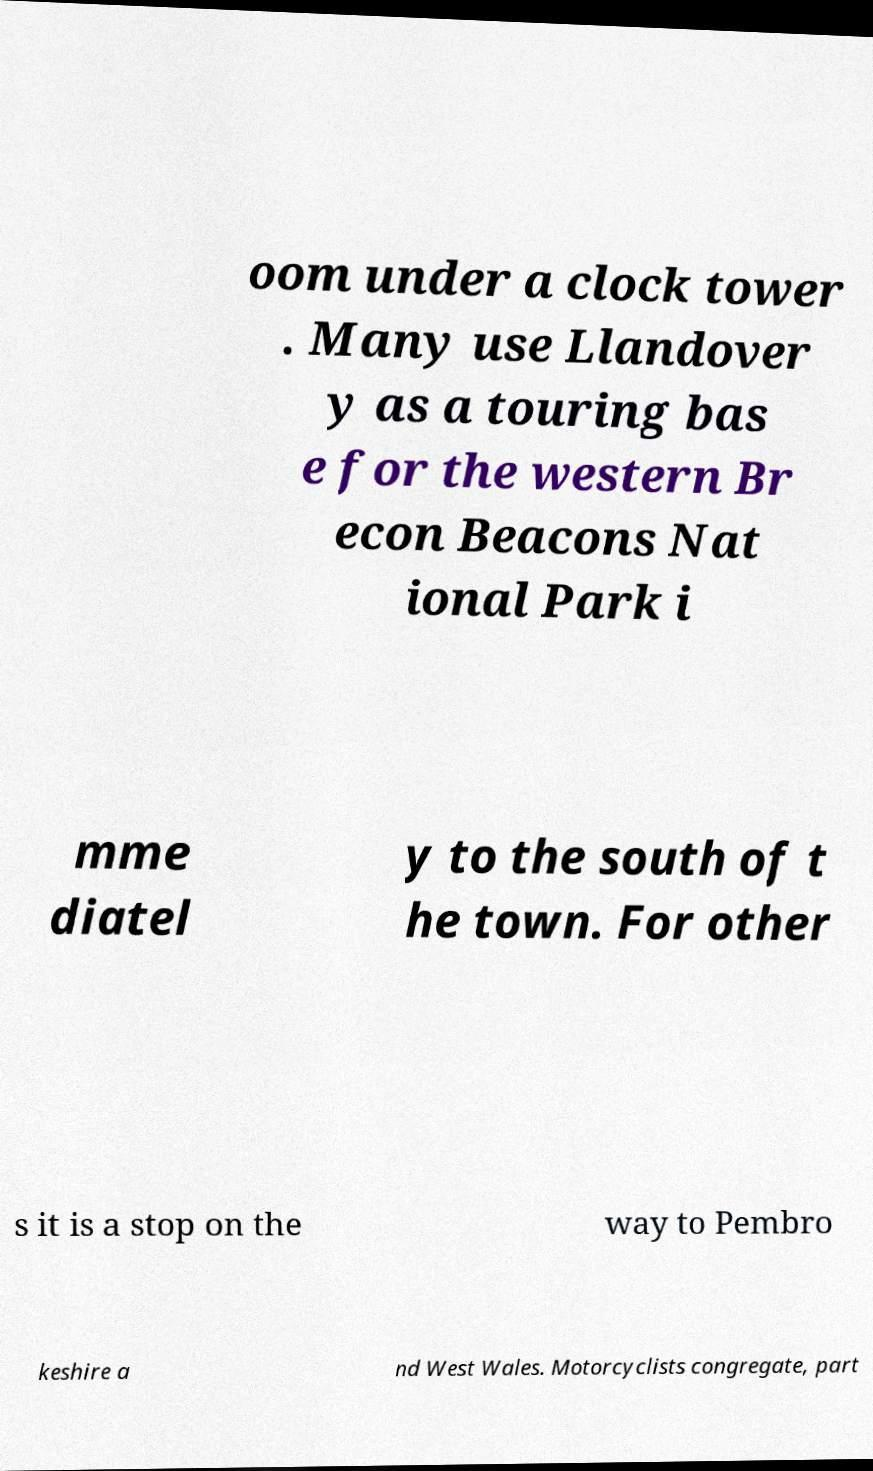Please identify and transcribe the text found in this image. oom under a clock tower . Many use Llandover y as a touring bas e for the western Br econ Beacons Nat ional Park i mme diatel y to the south of t he town. For other s it is a stop on the way to Pembro keshire a nd West Wales. Motorcyclists congregate, part 